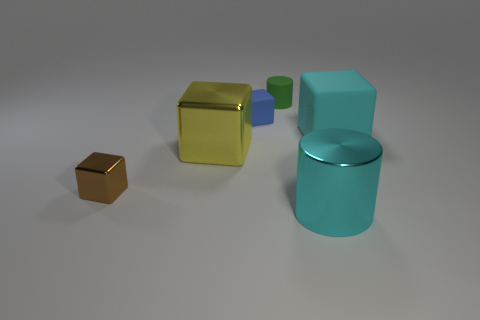Subtract all large shiny cubes. How many cubes are left? 3 Subtract all cyan cubes. How many cubes are left? 3 Subtract all purple cubes. Subtract all yellow spheres. How many cubes are left? 4 Add 4 tiny blue cubes. How many objects exist? 10 Subtract all cubes. How many objects are left? 2 Subtract 0 yellow cylinders. How many objects are left? 6 Subtract all small blue things. Subtract all small brown metallic things. How many objects are left? 4 Add 4 tiny blue cubes. How many tiny blue cubes are left? 5 Add 6 small blocks. How many small blocks exist? 8 